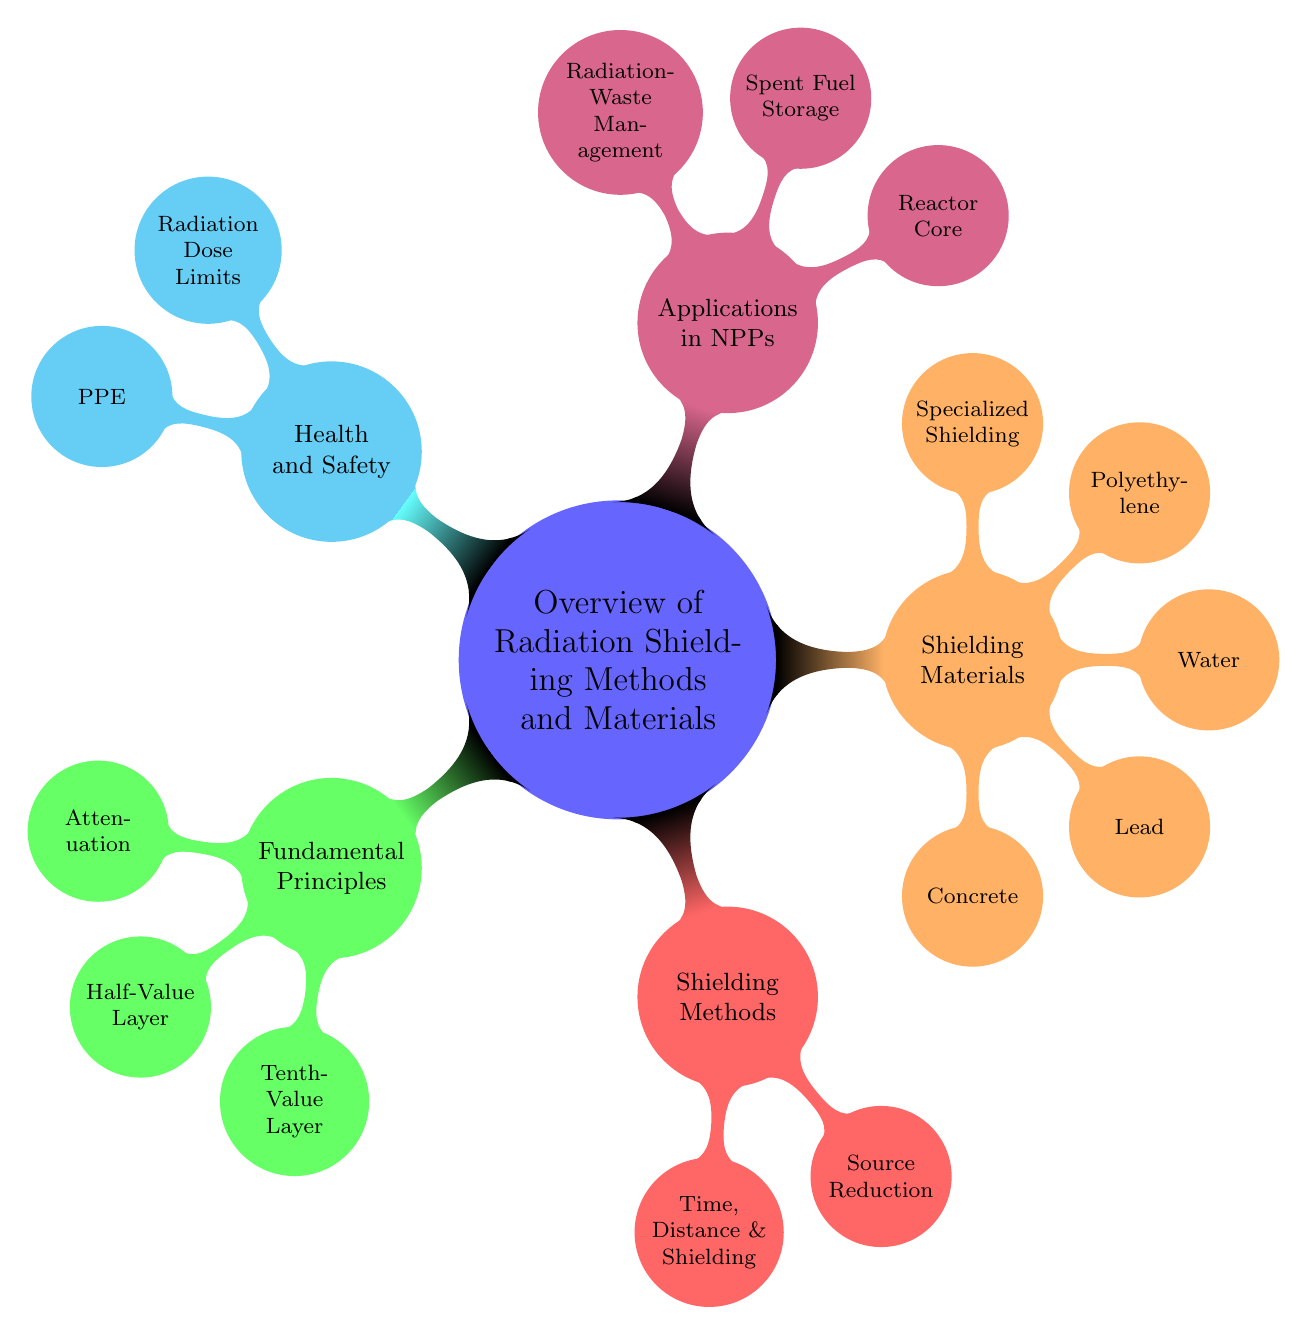What are the two main components of the fundamental principles of radiation shielding? The diagram shows "Attenuation" as a sub-node under "Fundamental Principles," along with "Half-Value Layer" and "Tenth-Value Layer." The question focuses specifically on the first two components, which are mentioned directly under this node.
Answer: Attenuation, Half-Value Layer How many types of shielding materials are listed in the diagram? The diagram indicates five main nodes under "Shielding Materials": Concrete, Lead, Water, Polyethylene, and Specialized Shielding. Counting these gives us the total number of different types of shielding materials shown.
Answer: Five What are the two methods included under "Time, Distance, and Shielding"? Within the "Shielding Methods" node, "Time, Distance, and Shielding" has three specific strategies listed; however, two prominent methods emphasized here are "Minimize Exposure Time" and "Maximize Distance from Source." The focus on the request is directed at the key strategies enumerated.
Answer: Minimize Exposure Time, Maximize Distance from Source What is the primary application for radiation shielding in nuclear power plants as indicated in the diagram? The mind map highlights "Applications in Nuclear Power Plants," which includes three sub-nodes. The core ones include "Reactor Core," which signifies the main area of focus for radiation shielding applications within a nuclear power context.
Answer: Reactor Core What materials are specifically classified under "Specialized Shielding"? The "Specialized Shielding" category under "Shielding Materials" of the mind map lists two specific materials, which are notable for their unique shielding properties in nuclear applications. These are clearly labeled in the mind map as the focus of this category.
Answer: Tungsten, Depleted Uranium What are the two specified radiation dose limits mentioned in the health and safety considerations? In the section titled "Radiation Dose Limits" under "Health and Safety Considerations," there are two key elements highlighted: "Occupational Exposure Limits" and "Public Exposure Limits." This captures the primary concerns regarding radiation exposure in the diagram's context.
Answer: Occupational Exposure Limits, Public Exposure Limits What form of shielding does "Boron-Doped Concrete" represent in the diagram? Within the "Concrete" node under "Shielding Materials," "Boron-Doped Concrete" is mentioned, indicating a specific category of concrete that is tailored for improved radiation shielding capability. It clarifies how this material is categorized and what its purpose is.
Answer: Concrete How many methods related to "Shielding Methods" are outlined in the diagram? The diagram categorizes "Shielding Methods" into two main areas: "Time, Distance and Shielding" and "Source Reduction." By reviewing the nodes under this category, we can determine how many main methods are illustrated within this section.
Answer: Two 